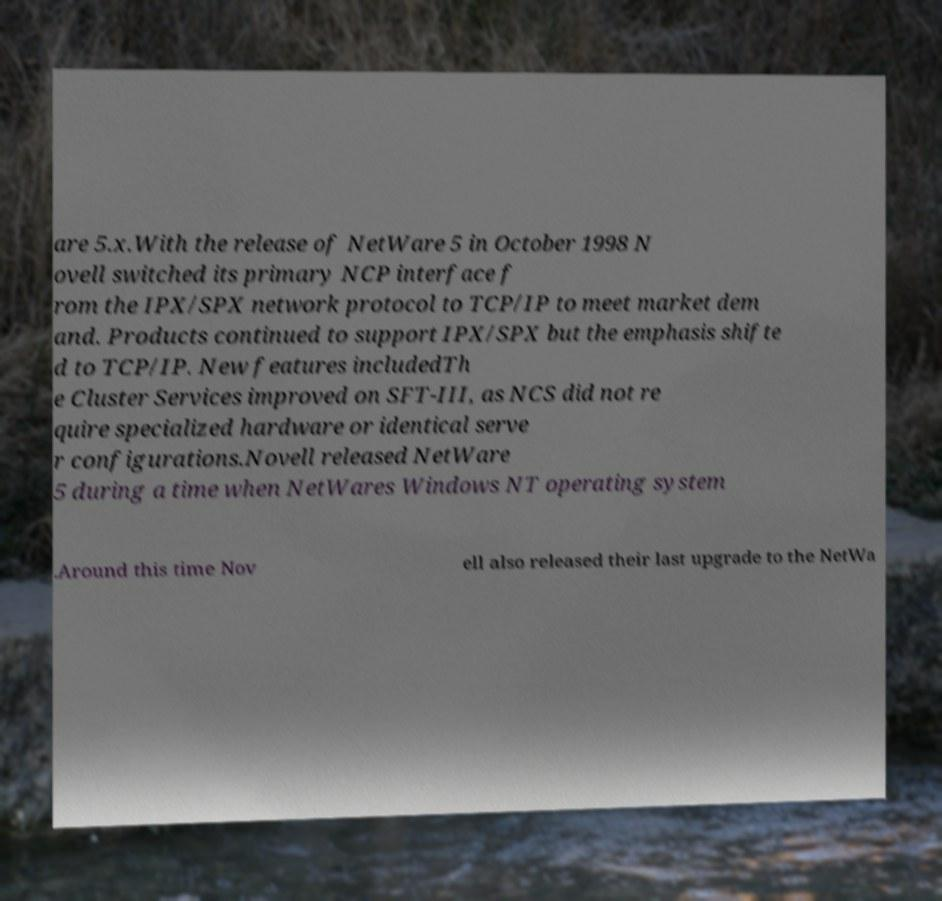Can you accurately transcribe the text from the provided image for me? are 5.x.With the release of NetWare 5 in October 1998 N ovell switched its primary NCP interface f rom the IPX/SPX network protocol to TCP/IP to meet market dem and. Products continued to support IPX/SPX but the emphasis shifte d to TCP/IP. New features includedTh e Cluster Services improved on SFT-III, as NCS did not re quire specialized hardware or identical serve r configurations.Novell released NetWare 5 during a time when NetWares Windows NT operating system .Around this time Nov ell also released their last upgrade to the NetWa 